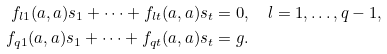Convert formula to latex. <formula><loc_0><loc_0><loc_500><loc_500>f _ { l 1 } ( a , a ) s _ { 1 } + \dots + f _ { l t } ( a , a ) s _ { t } & = 0 , \quad l = 1 , \dots , q - 1 , \\ f _ { q 1 } ( a , a ) s _ { 1 } + \dots + f _ { q t } ( a , a ) s _ { t } & = g .</formula> 